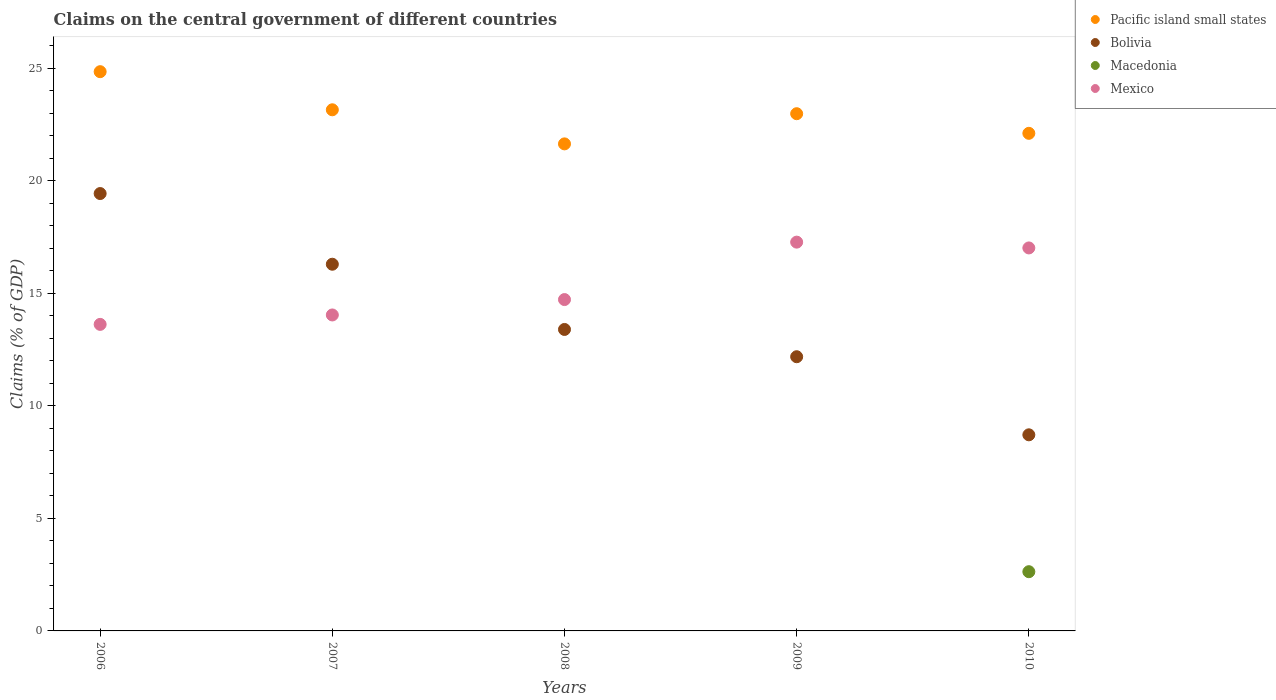How many different coloured dotlines are there?
Your answer should be compact. 4. What is the percentage of GDP claimed on the central government in Bolivia in 2010?
Ensure brevity in your answer.  8.72. Across all years, what is the maximum percentage of GDP claimed on the central government in Mexico?
Offer a terse response. 17.28. Across all years, what is the minimum percentage of GDP claimed on the central government in Bolivia?
Give a very brief answer. 8.72. What is the total percentage of GDP claimed on the central government in Mexico in the graph?
Make the answer very short. 76.7. What is the difference between the percentage of GDP claimed on the central government in Pacific island small states in 2007 and that in 2009?
Ensure brevity in your answer.  0.17. What is the difference between the percentage of GDP claimed on the central government in Bolivia in 2006 and the percentage of GDP claimed on the central government in Mexico in 2010?
Your response must be concise. 2.42. What is the average percentage of GDP claimed on the central government in Mexico per year?
Offer a terse response. 15.34. In the year 2010, what is the difference between the percentage of GDP claimed on the central government in Mexico and percentage of GDP claimed on the central government in Pacific island small states?
Provide a succinct answer. -5.09. What is the ratio of the percentage of GDP claimed on the central government in Mexico in 2007 to that in 2008?
Your answer should be compact. 0.95. Is the percentage of GDP claimed on the central government in Bolivia in 2006 less than that in 2010?
Keep it short and to the point. No. What is the difference between the highest and the second highest percentage of GDP claimed on the central government in Bolivia?
Your response must be concise. 3.14. What is the difference between the highest and the lowest percentage of GDP claimed on the central government in Macedonia?
Give a very brief answer. 2.63. In how many years, is the percentage of GDP claimed on the central government in Mexico greater than the average percentage of GDP claimed on the central government in Mexico taken over all years?
Offer a very short reply. 2. Is the sum of the percentage of GDP claimed on the central government in Pacific island small states in 2006 and 2008 greater than the maximum percentage of GDP claimed on the central government in Mexico across all years?
Offer a very short reply. Yes. Is it the case that in every year, the sum of the percentage of GDP claimed on the central government in Pacific island small states and percentage of GDP claimed on the central government in Mexico  is greater than the percentage of GDP claimed on the central government in Macedonia?
Your answer should be compact. Yes. Is the percentage of GDP claimed on the central government in Bolivia strictly greater than the percentage of GDP claimed on the central government in Mexico over the years?
Offer a terse response. No. How many years are there in the graph?
Your response must be concise. 5. What is the difference between two consecutive major ticks on the Y-axis?
Offer a terse response. 5. Does the graph contain grids?
Offer a terse response. No. Where does the legend appear in the graph?
Make the answer very short. Top right. How many legend labels are there?
Provide a succinct answer. 4. What is the title of the graph?
Keep it short and to the point. Claims on the central government of different countries. Does "Estonia" appear as one of the legend labels in the graph?
Offer a terse response. No. What is the label or title of the Y-axis?
Your response must be concise. Claims (% of GDP). What is the Claims (% of GDP) of Pacific island small states in 2006?
Provide a short and direct response. 24.86. What is the Claims (% of GDP) of Bolivia in 2006?
Offer a very short reply. 19.44. What is the Claims (% of GDP) in Macedonia in 2006?
Your response must be concise. 0. What is the Claims (% of GDP) in Mexico in 2006?
Your answer should be compact. 13.63. What is the Claims (% of GDP) of Pacific island small states in 2007?
Provide a short and direct response. 23.16. What is the Claims (% of GDP) of Bolivia in 2007?
Provide a short and direct response. 16.3. What is the Claims (% of GDP) in Mexico in 2007?
Give a very brief answer. 14.04. What is the Claims (% of GDP) in Pacific island small states in 2008?
Provide a succinct answer. 21.65. What is the Claims (% of GDP) in Bolivia in 2008?
Offer a very short reply. 13.4. What is the Claims (% of GDP) of Macedonia in 2008?
Provide a short and direct response. 0. What is the Claims (% of GDP) in Mexico in 2008?
Give a very brief answer. 14.73. What is the Claims (% of GDP) of Pacific island small states in 2009?
Your answer should be very brief. 22.99. What is the Claims (% of GDP) in Bolivia in 2009?
Make the answer very short. 12.19. What is the Claims (% of GDP) in Mexico in 2009?
Your answer should be very brief. 17.28. What is the Claims (% of GDP) in Pacific island small states in 2010?
Provide a short and direct response. 22.12. What is the Claims (% of GDP) of Bolivia in 2010?
Offer a terse response. 8.72. What is the Claims (% of GDP) in Macedonia in 2010?
Your answer should be very brief. 2.63. What is the Claims (% of GDP) in Mexico in 2010?
Your answer should be compact. 17.02. Across all years, what is the maximum Claims (% of GDP) in Pacific island small states?
Your answer should be compact. 24.86. Across all years, what is the maximum Claims (% of GDP) in Bolivia?
Your response must be concise. 19.44. Across all years, what is the maximum Claims (% of GDP) in Macedonia?
Offer a terse response. 2.63. Across all years, what is the maximum Claims (% of GDP) in Mexico?
Your answer should be very brief. 17.28. Across all years, what is the minimum Claims (% of GDP) of Pacific island small states?
Offer a terse response. 21.65. Across all years, what is the minimum Claims (% of GDP) of Bolivia?
Offer a very short reply. 8.72. Across all years, what is the minimum Claims (% of GDP) of Macedonia?
Offer a terse response. 0. Across all years, what is the minimum Claims (% of GDP) of Mexico?
Make the answer very short. 13.63. What is the total Claims (% of GDP) in Pacific island small states in the graph?
Give a very brief answer. 114.78. What is the total Claims (% of GDP) in Bolivia in the graph?
Offer a terse response. 70.04. What is the total Claims (% of GDP) in Macedonia in the graph?
Provide a short and direct response. 2.63. What is the total Claims (% of GDP) of Mexico in the graph?
Ensure brevity in your answer.  76.7. What is the difference between the Claims (% of GDP) of Pacific island small states in 2006 and that in 2007?
Ensure brevity in your answer.  1.69. What is the difference between the Claims (% of GDP) in Bolivia in 2006 and that in 2007?
Offer a very short reply. 3.14. What is the difference between the Claims (% of GDP) in Mexico in 2006 and that in 2007?
Keep it short and to the point. -0.42. What is the difference between the Claims (% of GDP) in Pacific island small states in 2006 and that in 2008?
Your answer should be very brief. 3.21. What is the difference between the Claims (% of GDP) in Bolivia in 2006 and that in 2008?
Keep it short and to the point. 6.04. What is the difference between the Claims (% of GDP) in Mexico in 2006 and that in 2008?
Give a very brief answer. -1.1. What is the difference between the Claims (% of GDP) of Pacific island small states in 2006 and that in 2009?
Your response must be concise. 1.87. What is the difference between the Claims (% of GDP) of Bolivia in 2006 and that in 2009?
Keep it short and to the point. 7.25. What is the difference between the Claims (% of GDP) in Mexico in 2006 and that in 2009?
Your answer should be compact. -3.66. What is the difference between the Claims (% of GDP) in Pacific island small states in 2006 and that in 2010?
Ensure brevity in your answer.  2.74. What is the difference between the Claims (% of GDP) in Bolivia in 2006 and that in 2010?
Your response must be concise. 10.72. What is the difference between the Claims (% of GDP) in Mexico in 2006 and that in 2010?
Your response must be concise. -3.4. What is the difference between the Claims (% of GDP) of Pacific island small states in 2007 and that in 2008?
Provide a succinct answer. 1.52. What is the difference between the Claims (% of GDP) in Bolivia in 2007 and that in 2008?
Provide a short and direct response. 2.9. What is the difference between the Claims (% of GDP) in Mexico in 2007 and that in 2008?
Give a very brief answer. -0.68. What is the difference between the Claims (% of GDP) in Pacific island small states in 2007 and that in 2009?
Make the answer very short. 0.17. What is the difference between the Claims (% of GDP) of Bolivia in 2007 and that in 2009?
Your answer should be very brief. 4.11. What is the difference between the Claims (% of GDP) in Mexico in 2007 and that in 2009?
Make the answer very short. -3.24. What is the difference between the Claims (% of GDP) in Pacific island small states in 2007 and that in 2010?
Your response must be concise. 1.05. What is the difference between the Claims (% of GDP) in Bolivia in 2007 and that in 2010?
Make the answer very short. 7.58. What is the difference between the Claims (% of GDP) of Mexico in 2007 and that in 2010?
Provide a short and direct response. -2.98. What is the difference between the Claims (% of GDP) in Pacific island small states in 2008 and that in 2009?
Give a very brief answer. -1.34. What is the difference between the Claims (% of GDP) of Bolivia in 2008 and that in 2009?
Offer a terse response. 1.21. What is the difference between the Claims (% of GDP) of Mexico in 2008 and that in 2009?
Provide a short and direct response. -2.55. What is the difference between the Claims (% of GDP) in Pacific island small states in 2008 and that in 2010?
Offer a terse response. -0.47. What is the difference between the Claims (% of GDP) in Bolivia in 2008 and that in 2010?
Offer a terse response. 4.68. What is the difference between the Claims (% of GDP) in Mexico in 2008 and that in 2010?
Provide a succinct answer. -2.29. What is the difference between the Claims (% of GDP) of Pacific island small states in 2009 and that in 2010?
Make the answer very short. 0.87. What is the difference between the Claims (% of GDP) in Bolivia in 2009 and that in 2010?
Your answer should be very brief. 3.47. What is the difference between the Claims (% of GDP) in Mexico in 2009 and that in 2010?
Your answer should be very brief. 0.26. What is the difference between the Claims (% of GDP) of Pacific island small states in 2006 and the Claims (% of GDP) of Bolivia in 2007?
Your answer should be very brief. 8.56. What is the difference between the Claims (% of GDP) in Pacific island small states in 2006 and the Claims (% of GDP) in Mexico in 2007?
Your response must be concise. 10.81. What is the difference between the Claims (% of GDP) of Bolivia in 2006 and the Claims (% of GDP) of Mexico in 2007?
Your answer should be very brief. 5.4. What is the difference between the Claims (% of GDP) of Pacific island small states in 2006 and the Claims (% of GDP) of Bolivia in 2008?
Keep it short and to the point. 11.46. What is the difference between the Claims (% of GDP) of Pacific island small states in 2006 and the Claims (% of GDP) of Mexico in 2008?
Provide a succinct answer. 10.13. What is the difference between the Claims (% of GDP) in Bolivia in 2006 and the Claims (% of GDP) in Mexico in 2008?
Give a very brief answer. 4.71. What is the difference between the Claims (% of GDP) in Pacific island small states in 2006 and the Claims (% of GDP) in Bolivia in 2009?
Your answer should be compact. 12.67. What is the difference between the Claims (% of GDP) in Pacific island small states in 2006 and the Claims (% of GDP) in Mexico in 2009?
Offer a terse response. 7.58. What is the difference between the Claims (% of GDP) of Bolivia in 2006 and the Claims (% of GDP) of Mexico in 2009?
Make the answer very short. 2.16. What is the difference between the Claims (% of GDP) in Pacific island small states in 2006 and the Claims (% of GDP) in Bolivia in 2010?
Make the answer very short. 16.14. What is the difference between the Claims (% of GDP) of Pacific island small states in 2006 and the Claims (% of GDP) of Macedonia in 2010?
Your answer should be compact. 22.23. What is the difference between the Claims (% of GDP) in Pacific island small states in 2006 and the Claims (% of GDP) in Mexico in 2010?
Ensure brevity in your answer.  7.83. What is the difference between the Claims (% of GDP) in Bolivia in 2006 and the Claims (% of GDP) in Macedonia in 2010?
Make the answer very short. 16.81. What is the difference between the Claims (% of GDP) of Bolivia in 2006 and the Claims (% of GDP) of Mexico in 2010?
Ensure brevity in your answer.  2.42. What is the difference between the Claims (% of GDP) of Pacific island small states in 2007 and the Claims (% of GDP) of Bolivia in 2008?
Your response must be concise. 9.76. What is the difference between the Claims (% of GDP) of Pacific island small states in 2007 and the Claims (% of GDP) of Mexico in 2008?
Provide a short and direct response. 8.44. What is the difference between the Claims (% of GDP) of Bolivia in 2007 and the Claims (% of GDP) of Mexico in 2008?
Ensure brevity in your answer.  1.57. What is the difference between the Claims (% of GDP) of Pacific island small states in 2007 and the Claims (% of GDP) of Bolivia in 2009?
Keep it short and to the point. 10.98. What is the difference between the Claims (% of GDP) of Pacific island small states in 2007 and the Claims (% of GDP) of Mexico in 2009?
Your answer should be compact. 5.88. What is the difference between the Claims (% of GDP) in Bolivia in 2007 and the Claims (% of GDP) in Mexico in 2009?
Your answer should be compact. -0.98. What is the difference between the Claims (% of GDP) of Pacific island small states in 2007 and the Claims (% of GDP) of Bolivia in 2010?
Keep it short and to the point. 14.45. What is the difference between the Claims (% of GDP) of Pacific island small states in 2007 and the Claims (% of GDP) of Macedonia in 2010?
Offer a terse response. 20.53. What is the difference between the Claims (% of GDP) in Pacific island small states in 2007 and the Claims (% of GDP) in Mexico in 2010?
Make the answer very short. 6.14. What is the difference between the Claims (% of GDP) of Bolivia in 2007 and the Claims (% of GDP) of Macedonia in 2010?
Provide a succinct answer. 13.67. What is the difference between the Claims (% of GDP) of Bolivia in 2007 and the Claims (% of GDP) of Mexico in 2010?
Your response must be concise. -0.72. What is the difference between the Claims (% of GDP) of Pacific island small states in 2008 and the Claims (% of GDP) of Bolivia in 2009?
Your answer should be very brief. 9.46. What is the difference between the Claims (% of GDP) of Pacific island small states in 2008 and the Claims (% of GDP) of Mexico in 2009?
Offer a very short reply. 4.37. What is the difference between the Claims (% of GDP) of Bolivia in 2008 and the Claims (% of GDP) of Mexico in 2009?
Your answer should be compact. -3.88. What is the difference between the Claims (% of GDP) of Pacific island small states in 2008 and the Claims (% of GDP) of Bolivia in 2010?
Your response must be concise. 12.93. What is the difference between the Claims (% of GDP) of Pacific island small states in 2008 and the Claims (% of GDP) of Macedonia in 2010?
Make the answer very short. 19.02. What is the difference between the Claims (% of GDP) in Pacific island small states in 2008 and the Claims (% of GDP) in Mexico in 2010?
Offer a terse response. 4.63. What is the difference between the Claims (% of GDP) in Bolivia in 2008 and the Claims (% of GDP) in Macedonia in 2010?
Ensure brevity in your answer.  10.77. What is the difference between the Claims (% of GDP) in Bolivia in 2008 and the Claims (% of GDP) in Mexico in 2010?
Your answer should be compact. -3.62. What is the difference between the Claims (% of GDP) in Pacific island small states in 2009 and the Claims (% of GDP) in Bolivia in 2010?
Keep it short and to the point. 14.27. What is the difference between the Claims (% of GDP) of Pacific island small states in 2009 and the Claims (% of GDP) of Macedonia in 2010?
Provide a short and direct response. 20.36. What is the difference between the Claims (% of GDP) of Pacific island small states in 2009 and the Claims (% of GDP) of Mexico in 2010?
Make the answer very short. 5.97. What is the difference between the Claims (% of GDP) of Bolivia in 2009 and the Claims (% of GDP) of Macedonia in 2010?
Your answer should be very brief. 9.56. What is the difference between the Claims (% of GDP) in Bolivia in 2009 and the Claims (% of GDP) in Mexico in 2010?
Keep it short and to the point. -4.84. What is the average Claims (% of GDP) of Pacific island small states per year?
Give a very brief answer. 22.96. What is the average Claims (% of GDP) of Bolivia per year?
Offer a very short reply. 14.01. What is the average Claims (% of GDP) in Macedonia per year?
Offer a very short reply. 0.53. What is the average Claims (% of GDP) in Mexico per year?
Give a very brief answer. 15.34. In the year 2006, what is the difference between the Claims (% of GDP) in Pacific island small states and Claims (% of GDP) in Bolivia?
Provide a succinct answer. 5.42. In the year 2006, what is the difference between the Claims (% of GDP) in Pacific island small states and Claims (% of GDP) in Mexico?
Offer a terse response. 11.23. In the year 2006, what is the difference between the Claims (% of GDP) in Bolivia and Claims (% of GDP) in Mexico?
Provide a short and direct response. 5.82. In the year 2007, what is the difference between the Claims (% of GDP) in Pacific island small states and Claims (% of GDP) in Bolivia?
Your answer should be very brief. 6.87. In the year 2007, what is the difference between the Claims (% of GDP) in Pacific island small states and Claims (% of GDP) in Mexico?
Give a very brief answer. 9.12. In the year 2007, what is the difference between the Claims (% of GDP) in Bolivia and Claims (% of GDP) in Mexico?
Provide a succinct answer. 2.25. In the year 2008, what is the difference between the Claims (% of GDP) in Pacific island small states and Claims (% of GDP) in Bolivia?
Your answer should be very brief. 8.25. In the year 2008, what is the difference between the Claims (% of GDP) in Pacific island small states and Claims (% of GDP) in Mexico?
Your answer should be compact. 6.92. In the year 2008, what is the difference between the Claims (% of GDP) of Bolivia and Claims (% of GDP) of Mexico?
Provide a succinct answer. -1.33. In the year 2009, what is the difference between the Claims (% of GDP) in Pacific island small states and Claims (% of GDP) in Bolivia?
Provide a succinct answer. 10.8. In the year 2009, what is the difference between the Claims (% of GDP) of Pacific island small states and Claims (% of GDP) of Mexico?
Offer a terse response. 5.71. In the year 2009, what is the difference between the Claims (% of GDP) of Bolivia and Claims (% of GDP) of Mexico?
Offer a terse response. -5.09. In the year 2010, what is the difference between the Claims (% of GDP) of Pacific island small states and Claims (% of GDP) of Bolivia?
Offer a very short reply. 13.4. In the year 2010, what is the difference between the Claims (% of GDP) in Pacific island small states and Claims (% of GDP) in Macedonia?
Your answer should be very brief. 19.49. In the year 2010, what is the difference between the Claims (% of GDP) in Pacific island small states and Claims (% of GDP) in Mexico?
Ensure brevity in your answer.  5.09. In the year 2010, what is the difference between the Claims (% of GDP) of Bolivia and Claims (% of GDP) of Macedonia?
Offer a very short reply. 6.08. In the year 2010, what is the difference between the Claims (% of GDP) of Bolivia and Claims (% of GDP) of Mexico?
Your response must be concise. -8.31. In the year 2010, what is the difference between the Claims (% of GDP) of Macedonia and Claims (% of GDP) of Mexico?
Offer a very short reply. -14.39. What is the ratio of the Claims (% of GDP) of Pacific island small states in 2006 to that in 2007?
Offer a terse response. 1.07. What is the ratio of the Claims (% of GDP) in Bolivia in 2006 to that in 2007?
Offer a terse response. 1.19. What is the ratio of the Claims (% of GDP) of Mexico in 2006 to that in 2007?
Offer a very short reply. 0.97. What is the ratio of the Claims (% of GDP) in Pacific island small states in 2006 to that in 2008?
Your response must be concise. 1.15. What is the ratio of the Claims (% of GDP) of Bolivia in 2006 to that in 2008?
Your response must be concise. 1.45. What is the ratio of the Claims (% of GDP) of Mexico in 2006 to that in 2008?
Provide a succinct answer. 0.93. What is the ratio of the Claims (% of GDP) in Pacific island small states in 2006 to that in 2009?
Your response must be concise. 1.08. What is the ratio of the Claims (% of GDP) in Bolivia in 2006 to that in 2009?
Your answer should be compact. 1.6. What is the ratio of the Claims (% of GDP) of Mexico in 2006 to that in 2009?
Offer a terse response. 0.79. What is the ratio of the Claims (% of GDP) in Pacific island small states in 2006 to that in 2010?
Provide a short and direct response. 1.12. What is the ratio of the Claims (% of GDP) of Bolivia in 2006 to that in 2010?
Give a very brief answer. 2.23. What is the ratio of the Claims (% of GDP) in Mexico in 2006 to that in 2010?
Offer a terse response. 0.8. What is the ratio of the Claims (% of GDP) in Pacific island small states in 2007 to that in 2008?
Offer a terse response. 1.07. What is the ratio of the Claims (% of GDP) in Bolivia in 2007 to that in 2008?
Make the answer very short. 1.22. What is the ratio of the Claims (% of GDP) of Mexico in 2007 to that in 2008?
Your response must be concise. 0.95. What is the ratio of the Claims (% of GDP) in Pacific island small states in 2007 to that in 2009?
Offer a terse response. 1.01. What is the ratio of the Claims (% of GDP) in Bolivia in 2007 to that in 2009?
Provide a succinct answer. 1.34. What is the ratio of the Claims (% of GDP) of Mexico in 2007 to that in 2009?
Offer a terse response. 0.81. What is the ratio of the Claims (% of GDP) in Pacific island small states in 2007 to that in 2010?
Ensure brevity in your answer.  1.05. What is the ratio of the Claims (% of GDP) in Bolivia in 2007 to that in 2010?
Offer a terse response. 1.87. What is the ratio of the Claims (% of GDP) in Mexico in 2007 to that in 2010?
Your answer should be very brief. 0.82. What is the ratio of the Claims (% of GDP) of Pacific island small states in 2008 to that in 2009?
Provide a short and direct response. 0.94. What is the ratio of the Claims (% of GDP) in Bolivia in 2008 to that in 2009?
Make the answer very short. 1.1. What is the ratio of the Claims (% of GDP) of Mexico in 2008 to that in 2009?
Provide a short and direct response. 0.85. What is the ratio of the Claims (% of GDP) in Pacific island small states in 2008 to that in 2010?
Your response must be concise. 0.98. What is the ratio of the Claims (% of GDP) in Bolivia in 2008 to that in 2010?
Keep it short and to the point. 1.54. What is the ratio of the Claims (% of GDP) of Mexico in 2008 to that in 2010?
Provide a short and direct response. 0.87. What is the ratio of the Claims (% of GDP) of Pacific island small states in 2009 to that in 2010?
Ensure brevity in your answer.  1.04. What is the ratio of the Claims (% of GDP) in Bolivia in 2009 to that in 2010?
Offer a terse response. 1.4. What is the ratio of the Claims (% of GDP) of Mexico in 2009 to that in 2010?
Give a very brief answer. 1.02. What is the difference between the highest and the second highest Claims (% of GDP) in Pacific island small states?
Your answer should be compact. 1.69. What is the difference between the highest and the second highest Claims (% of GDP) of Bolivia?
Offer a terse response. 3.14. What is the difference between the highest and the second highest Claims (% of GDP) of Mexico?
Your answer should be compact. 0.26. What is the difference between the highest and the lowest Claims (% of GDP) in Pacific island small states?
Make the answer very short. 3.21. What is the difference between the highest and the lowest Claims (% of GDP) in Bolivia?
Your answer should be very brief. 10.72. What is the difference between the highest and the lowest Claims (% of GDP) of Macedonia?
Your answer should be very brief. 2.63. What is the difference between the highest and the lowest Claims (% of GDP) of Mexico?
Make the answer very short. 3.66. 